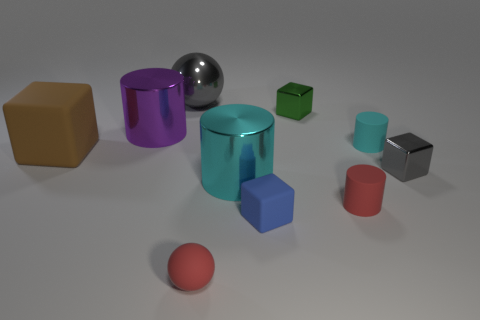Subtract all small red rubber cylinders. How many cylinders are left? 3 Subtract all blue blocks. How many blocks are left? 3 Subtract 1 blocks. How many blocks are left? 3 Subtract all cyan cylinders. Subtract all red spheres. How many cylinders are left? 2 Subtract all yellow blocks. How many cyan cylinders are left? 2 Subtract all green shiny blocks. Subtract all tiny red objects. How many objects are left? 7 Add 5 cyan metal objects. How many cyan metal objects are left? 6 Add 1 green matte balls. How many green matte balls exist? 1 Subtract 1 red balls. How many objects are left? 9 Subtract all cylinders. How many objects are left? 6 